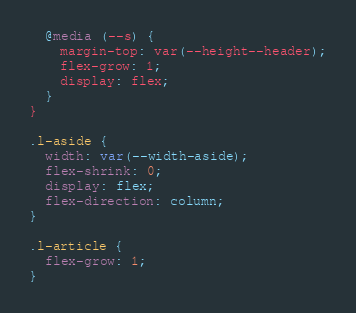Convert code to text. <code><loc_0><loc_0><loc_500><loc_500><_CSS_>  @media (--s) {
    margin-top: var(--height--header);
    flex-grow: 1;
    display: flex;
  }
}

.l-aside {
  width: var(--width-aside);
  flex-shrink: 0;
  display: flex;
  flex-direction: column;
}

.l-article {
  flex-grow: 1;
}
</code> 